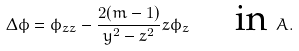Convert formula to latex. <formula><loc_0><loc_0><loc_500><loc_500>\Delta \phi = \phi _ { z z } - \frac { 2 ( m - 1 ) } { y ^ { 2 } - z ^ { 2 } } z \phi _ { z } \quad \text { in } A .</formula> 